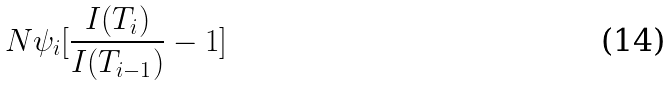Convert formula to latex. <formula><loc_0><loc_0><loc_500><loc_500>N \psi _ { i } [ \frac { I ( T _ { i } ) } { I ( T _ { i - 1 } ) } - 1 ]</formula> 